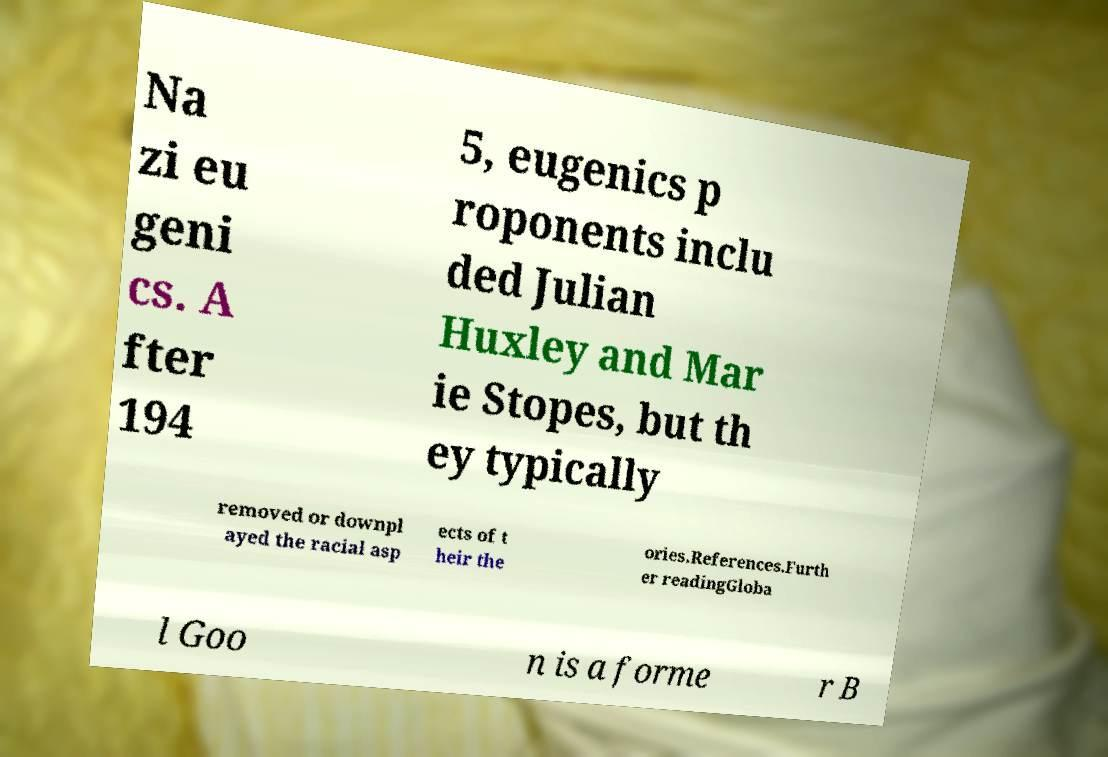Could you extract and type out the text from this image? Na zi eu geni cs. A fter 194 5, eugenics p roponents inclu ded Julian Huxley and Mar ie Stopes, but th ey typically removed or downpl ayed the racial asp ects of t heir the ories.References.Furth er readingGloba l Goo n is a forme r B 